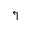<formula> <loc_0><loc_0><loc_500><loc_500>\L s h</formula> 